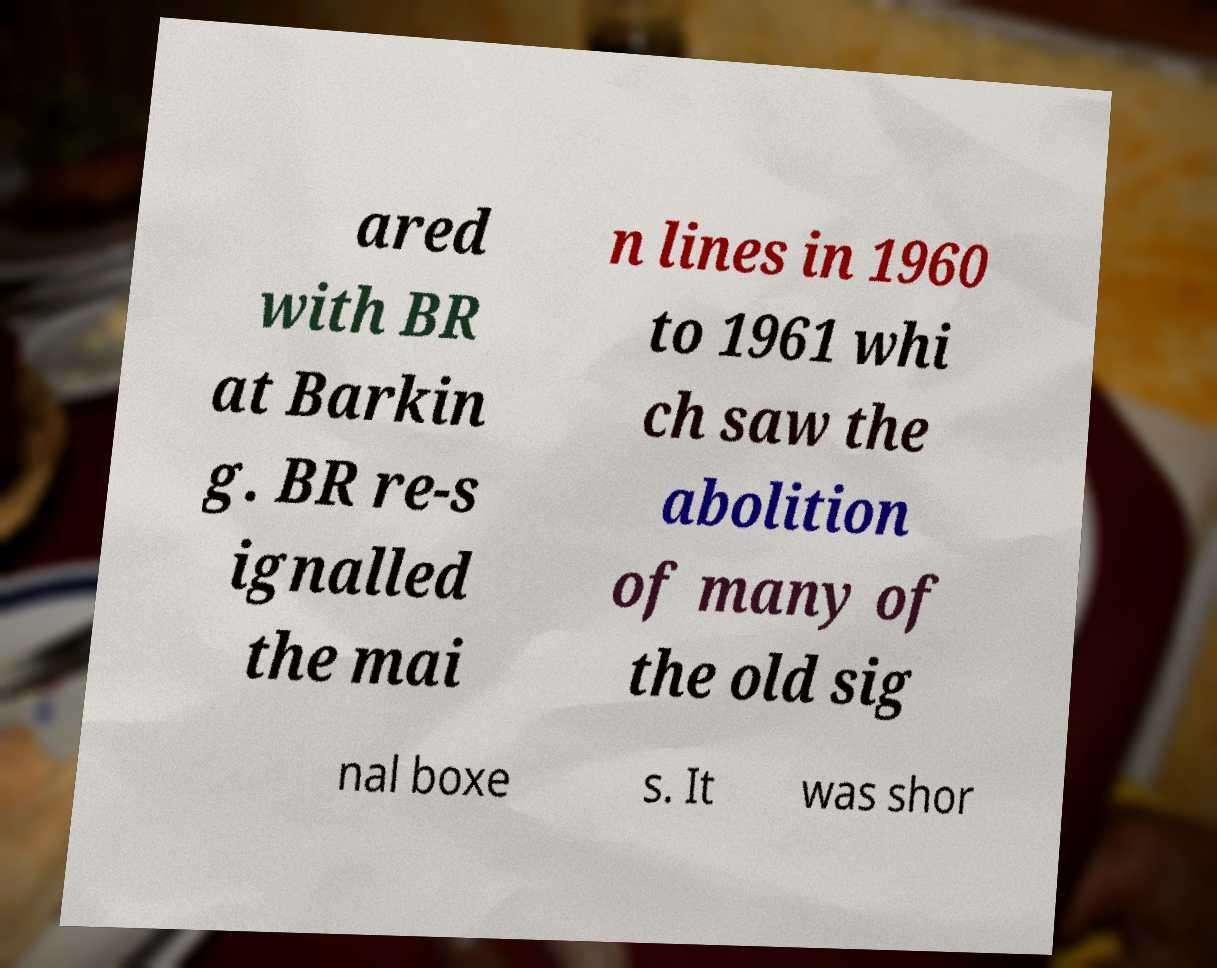For documentation purposes, I need the text within this image transcribed. Could you provide that? ared with BR at Barkin g. BR re-s ignalled the mai n lines in 1960 to 1961 whi ch saw the abolition of many of the old sig nal boxe s. It was shor 